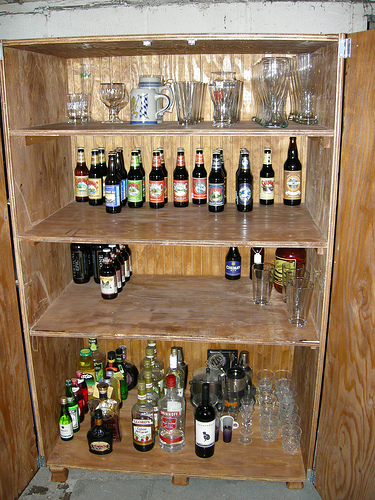<image>
Can you confirm if the bottle is to the left of the bottle? No. The bottle is not to the left of the bottle. From this viewpoint, they have a different horizontal relationship. 